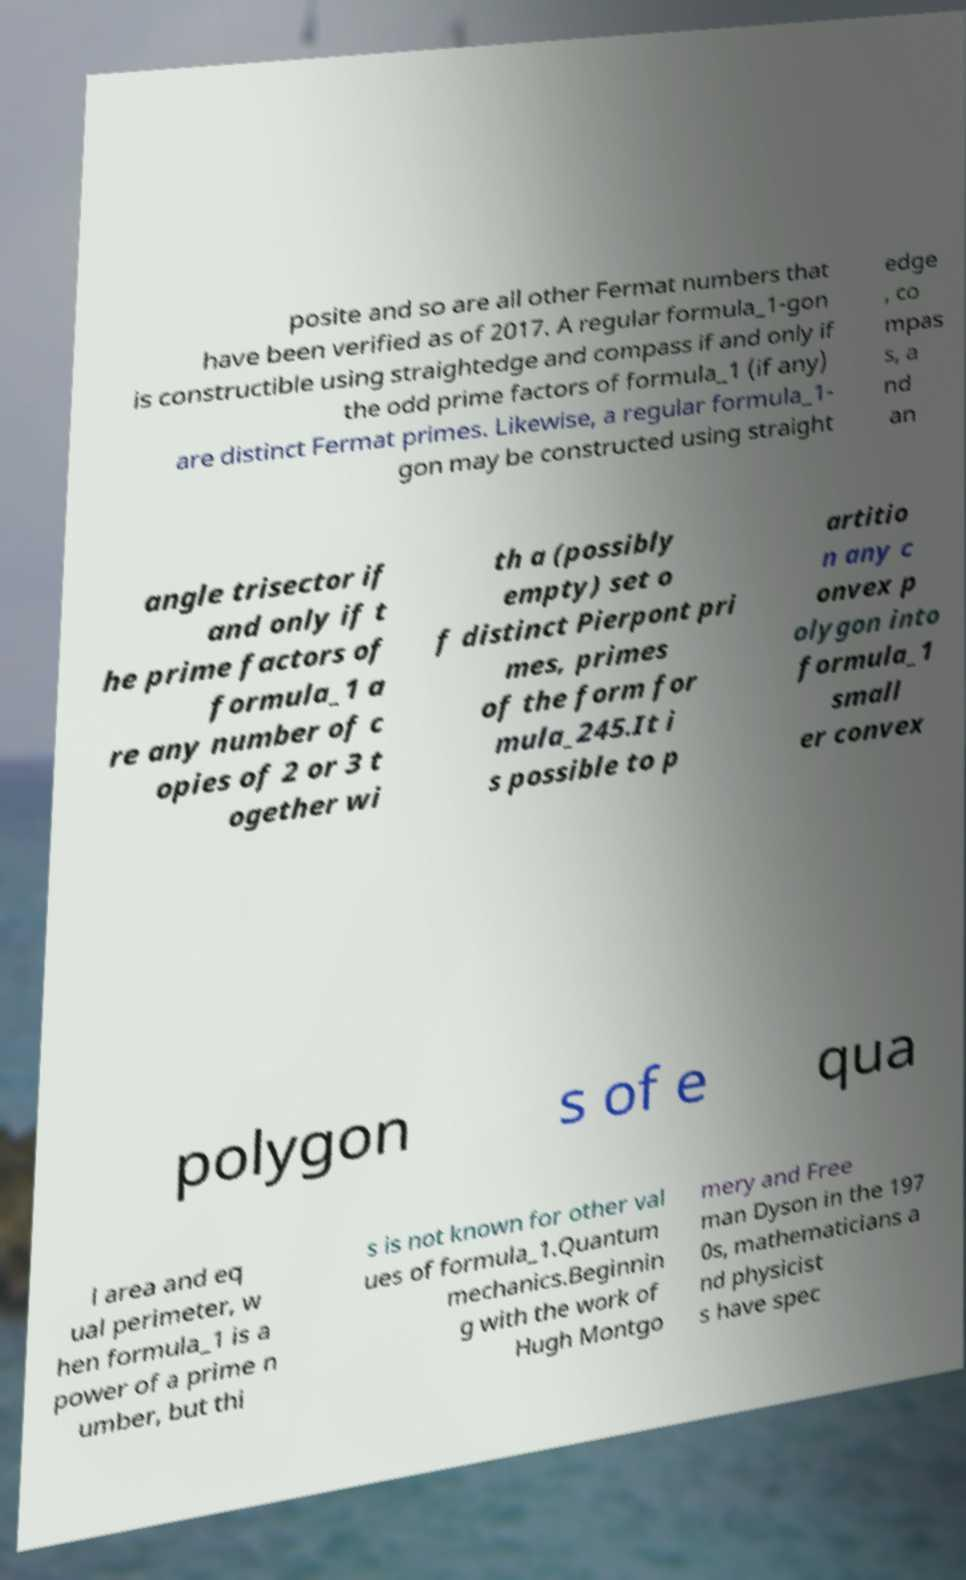Could you extract and type out the text from this image? posite and so are all other Fermat numbers that have been verified as of 2017. A regular formula_1-gon is constructible using straightedge and compass if and only if the odd prime factors of formula_1 (if any) are distinct Fermat primes. Likewise, a regular formula_1- gon may be constructed using straight edge , co mpas s, a nd an angle trisector if and only if t he prime factors of formula_1 a re any number of c opies of 2 or 3 t ogether wi th a (possibly empty) set o f distinct Pierpont pri mes, primes of the form for mula_245.It i s possible to p artitio n any c onvex p olygon into formula_1 small er convex polygon s of e qua l area and eq ual perimeter, w hen formula_1 is a power of a prime n umber, but thi s is not known for other val ues of formula_1.Quantum mechanics.Beginnin g with the work of Hugh Montgo mery and Free man Dyson in the 197 0s, mathematicians a nd physicist s have spec 